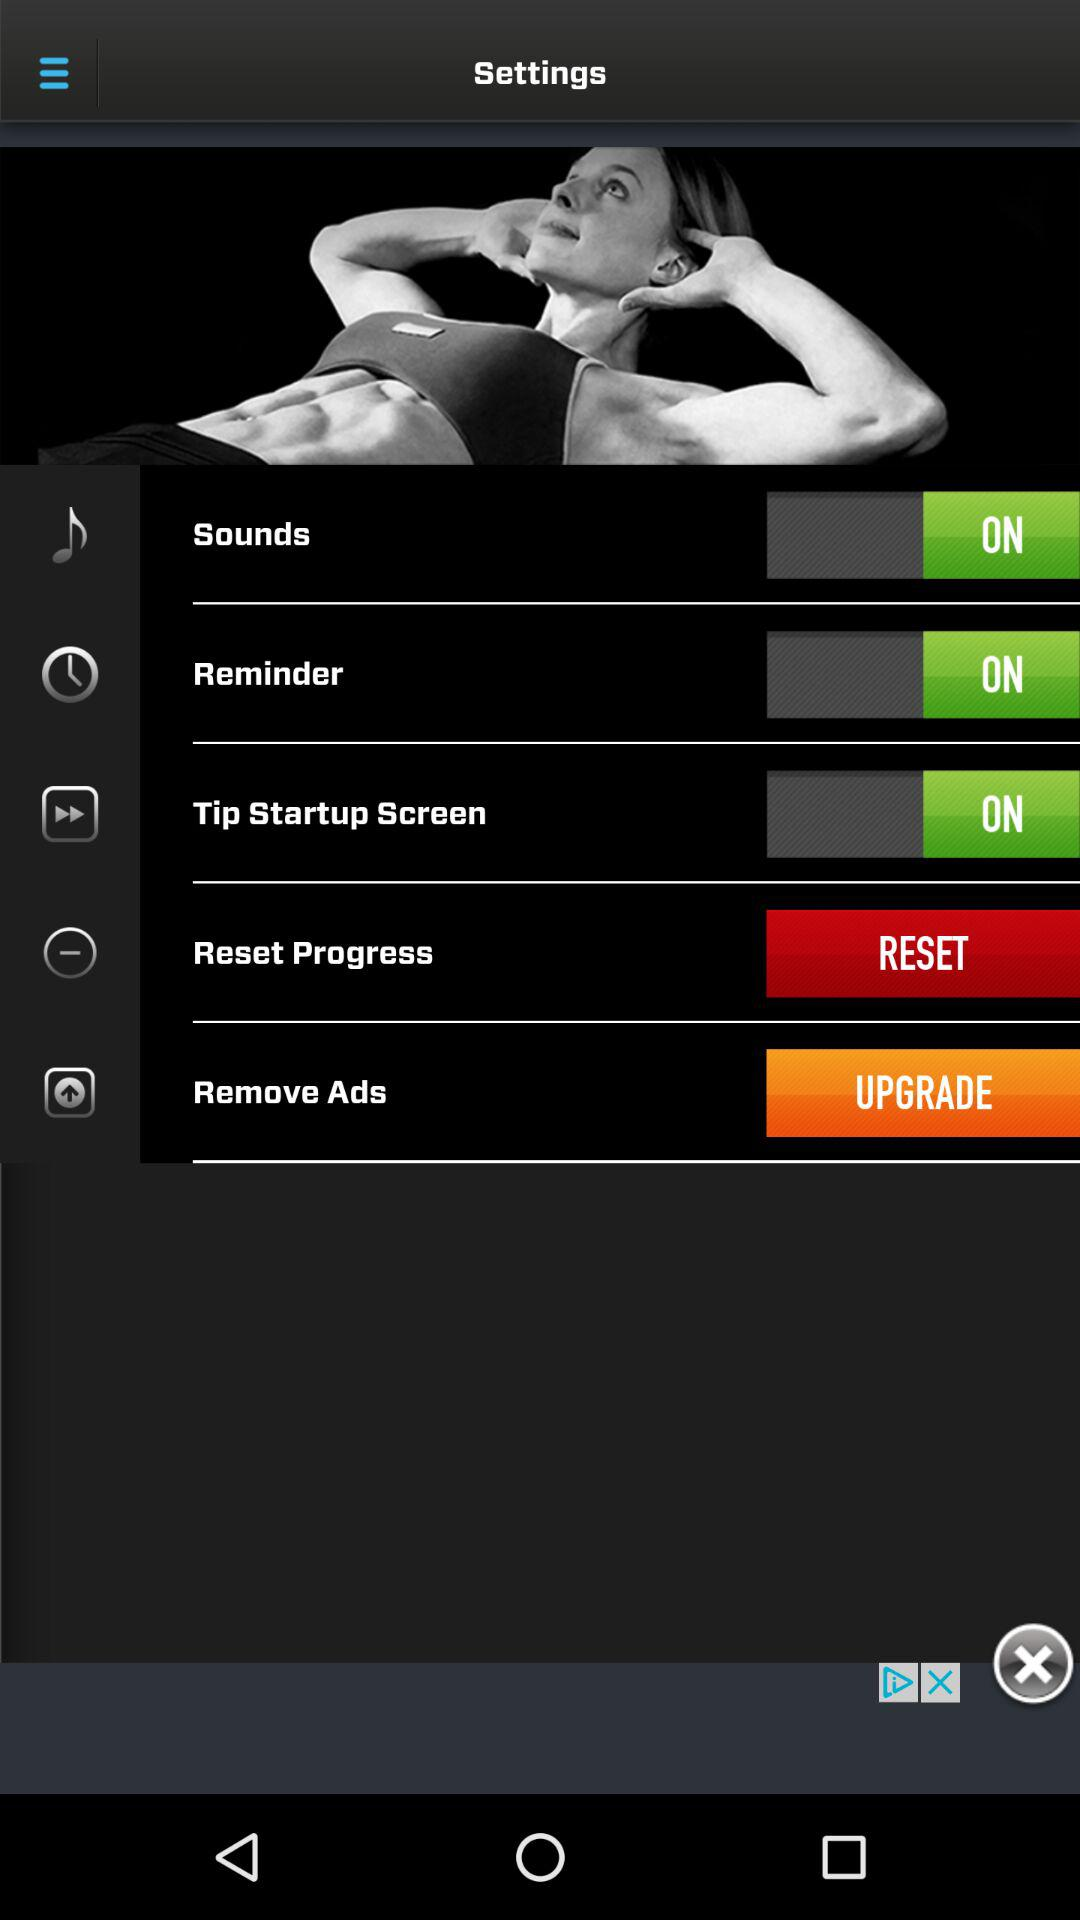What is the status of the "Reminder" setting? The status of the "Reminder" setting is "on". 